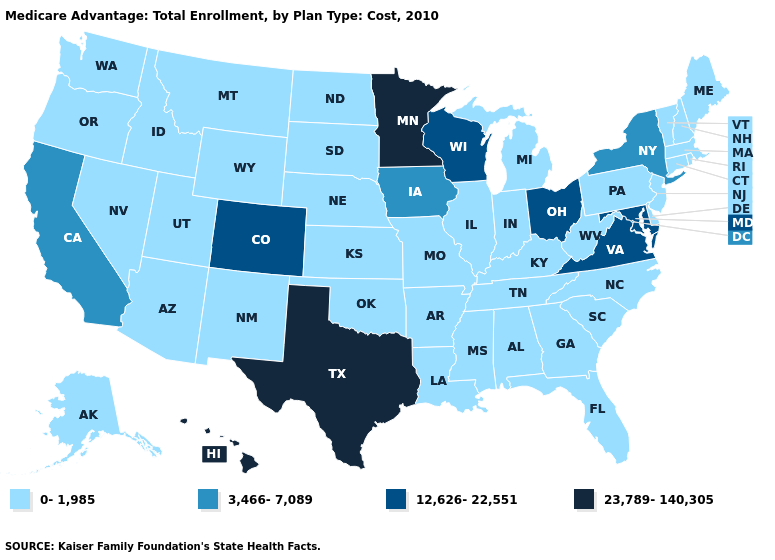Does Washington have the same value as Mississippi?
Write a very short answer. Yes. Among the states that border Arizona , does Utah have the highest value?
Write a very short answer. No. Which states hav the highest value in the Northeast?
Answer briefly. New York. What is the value of New Mexico?
Be succinct. 0-1,985. Which states have the highest value in the USA?
Keep it brief. Hawaii, Minnesota, Texas. Does the map have missing data?
Quick response, please. No. Which states have the lowest value in the Northeast?
Answer briefly. Connecticut, Massachusetts, Maine, New Hampshire, New Jersey, Pennsylvania, Rhode Island, Vermont. What is the highest value in the Northeast ?
Give a very brief answer. 3,466-7,089. Does Hawaii have the highest value in the USA?
Give a very brief answer. Yes. What is the lowest value in the USA?
Concise answer only. 0-1,985. What is the value of Wisconsin?
Quick response, please. 12,626-22,551. Among the states that border Oregon , does California have the lowest value?
Keep it brief. No. Among the states that border Wisconsin , does Iowa have the highest value?
Short answer required. No. Name the states that have a value in the range 3,466-7,089?
Concise answer only. California, Iowa, New York. What is the value of Rhode Island?
Be succinct. 0-1,985. 